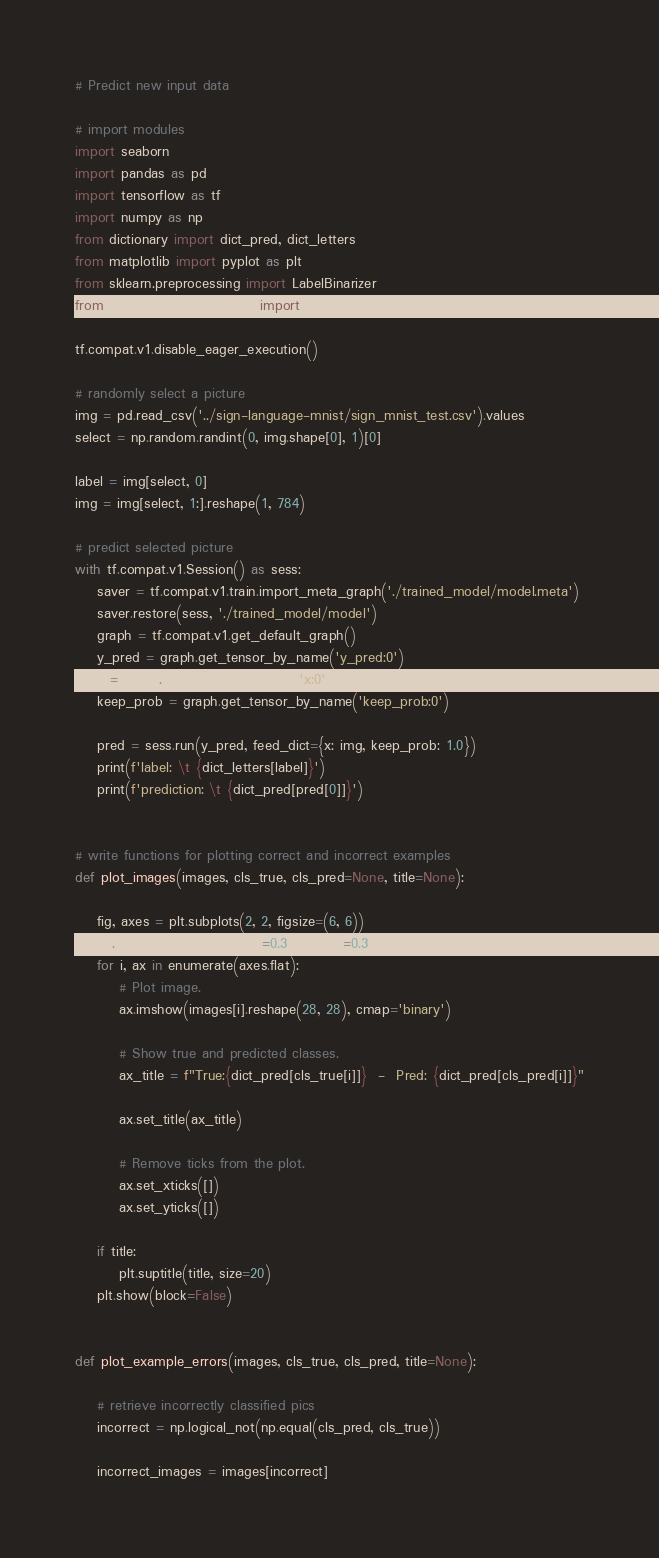Convert code to text. <code><loc_0><loc_0><loc_500><loc_500><_Python_># Predict new input data

# import modules
import seaborn
import pandas as pd
import tensorflow as tf
import numpy as np
from dictionary import dict_pred, dict_letters
from matplotlib import pyplot as plt
from sklearn.preprocessing import LabelBinarizer
from sklearn.model_selection import train_test_split

tf.compat.v1.disable_eager_execution()

# randomly select a picture
img = pd.read_csv('../sign-language-mnist/sign_mnist_test.csv').values
select = np.random.randint(0, img.shape[0], 1)[0]

label = img[select, 0]
img = img[select, 1:].reshape(1, 784)

# predict selected picture
with tf.compat.v1.Session() as sess:
    saver = tf.compat.v1.train.import_meta_graph('./trained_model/model.meta')
    saver.restore(sess, './trained_model/model')
    graph = tf.compat.v1.get_default_graph()
    y_pred = graph.get_tensor_by_name('y_pred:0')
    x = graph.get_tensor_by_name('x:0')
    keep_prob = graph.get_tensor_by_name('keep_prob:0')

    pred = sess.run(y_pred, feed_dict={x: img, keep_prob: 1.0})
    print(f'label: \t {dict_letters[label]}')
    print(f'prediction: \t {dict_pred[pred[0]]}')


# write functions for plotting correct and incorrect examples
def plot_images(images, cls_true, cls_pred=None, title=None):

    fig, axes = plt.subplots(2, 2, figsize=(6, 6))
    fig.subplots_adjust(hspace=0.3, wspace=0.3)
    for i, ax in enumerate(axes.flat):
        # Plot image.
        ax.imshow(images[i].reshape(28, 28), cmap='binary')

        # Show true and predicted classes.
        ax_title = f"True:{dict_pred[cls_true[i]]}  -  Pred: {dict_pred[cls_pred[i]]}"

        ax.set_title(ax_title)

        # Remove ticks from the plot.
        ax.set_xticks([])
        ax.set_yticks([])

    if title:
        plt.suptitle(title, size=20)
    plt.show(block=False)


def plot_example_errors(images, cls_true, cls_pred, title=None):

    # retrieve incorrectly classified pics
    incorrect = np.logical_not(np.equal(cls_pred, cls_true))

    incorrect_images = images[incorrect]
</code> 